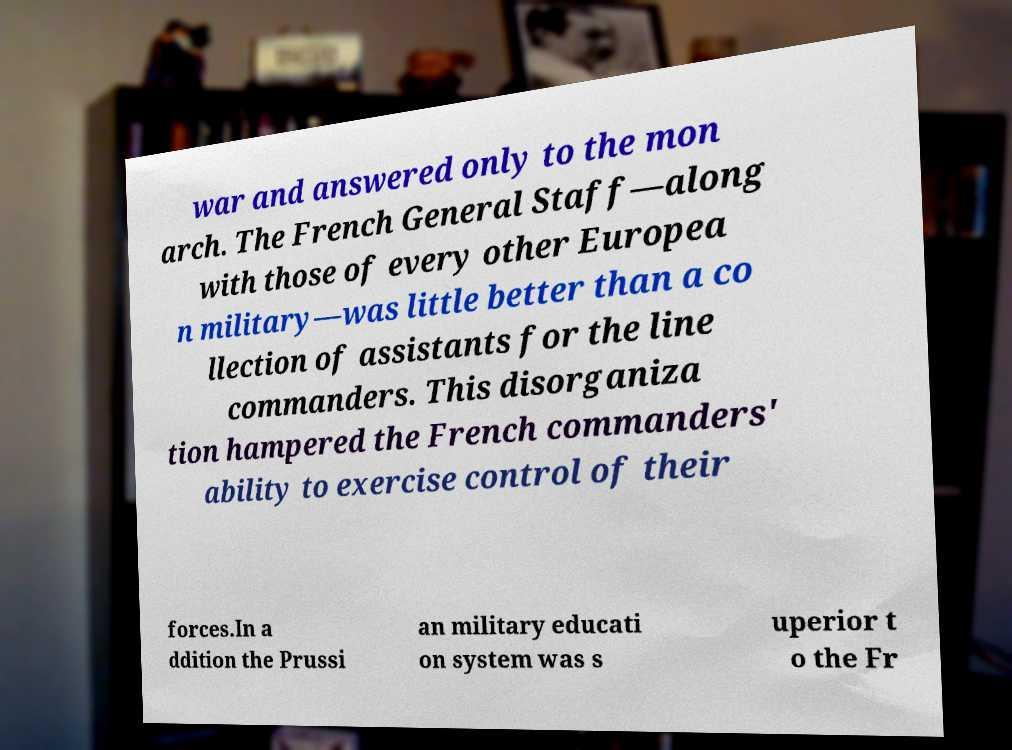There's text embedded in this image that I need extracted. Can you transcribe it verbatim? war and answered only to the mon arch. The French General Staff—along with those of every other Europea n military—was little better than a co llection of assistants for the line commanders. This disorganiza tion hampered the French commanders' ability to exercise control of their forces.In a ddition the Prussi an military educati on system was s uperior t o the Fr 